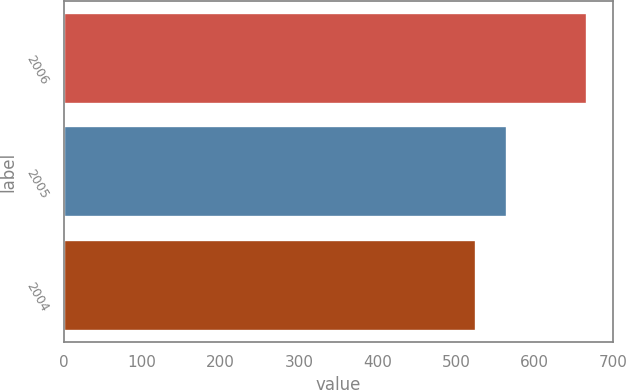Convert chart. <chart><loc_0><loc_0><loc_500><loc_500><bar_chart><fcel>2006<fcel>2005<fcel>2004<nl><fcel>667.4<fcel>564.6<fcel>525.5<nl></chart> 